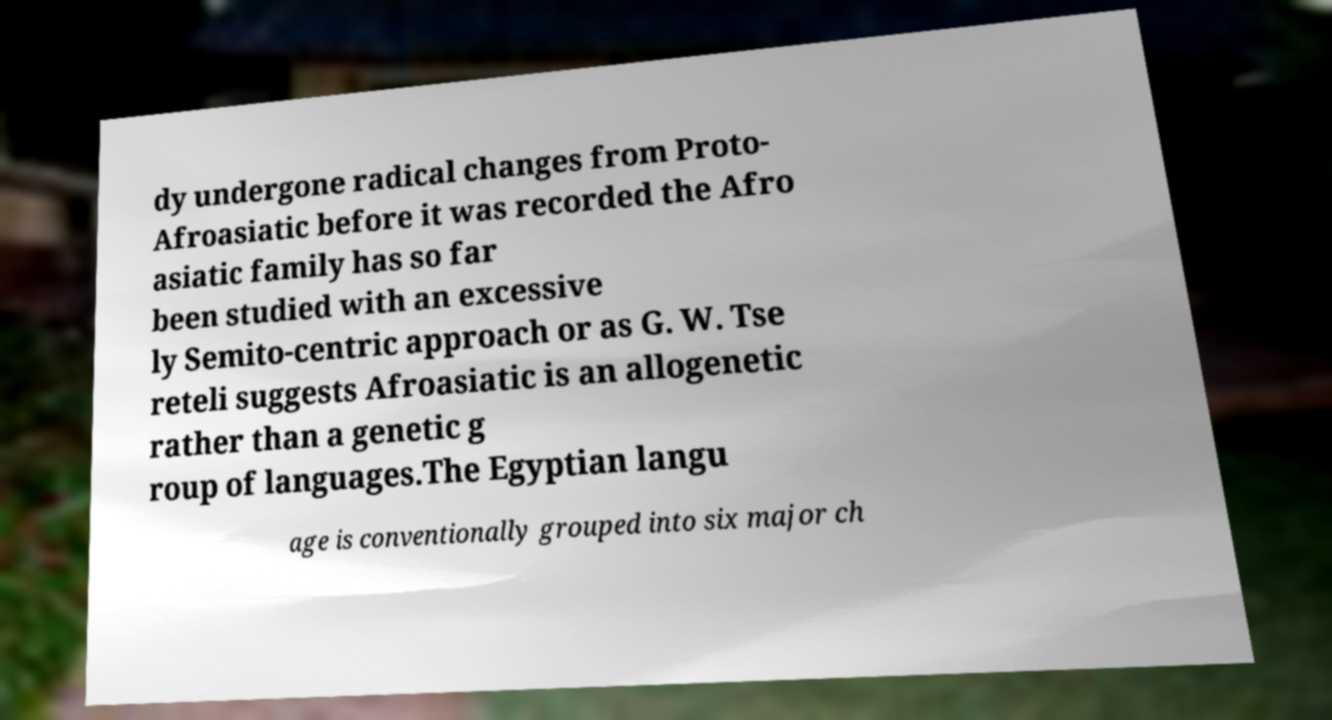Could you assist in decoding the text presented in this image and type it out clearly? dy undergone radical changes from Proto- Afroasiatic before it was recorded the Afro asiatic family has so far been studied with an excessive ly Semito-centric approach or as G. W. Tse reteli suggests Afroasiatic is an allogenetic rather than a genetic g roup of languages.The Egyptian langu age is conventionally grouped into six major ch 